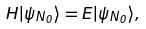<formula> <loc_0><loc_0><loc_500><loc_500>H | \psi _ { N _ { 0 } } \rangle = E | \psi _ { N _ { 0 } } \rangle ,</formula> 